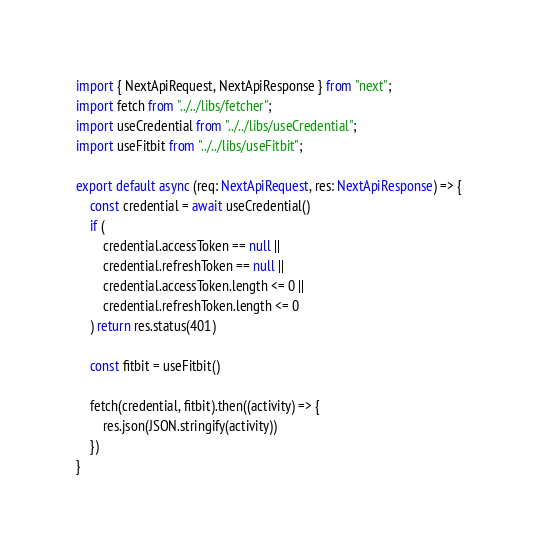<code> <loc_0><loc_0><loc_500><loc_500><_TypeScript_>import { NextApiRequest, NextApiResponse } from "next";
import fetch from "../../libs/fetcher";
import useCredential from "../../libs/useCredential";
import useFitbit from "../../libs/useFitbit";

export default async (req: NextApiRequest, res: NextApiResponse) => {
    const credential = await useCredential()
    if (
        credential.accessToken == null ||
        credential.refreshToken == null ||
        credential.accessToken.length <= 0 ||
        credential.refreshToken.length <= 0
    ) return res.status(401)

    const fitbit = useFitbit()

    fetch(credential, fitbit).then((activity) => {
        res.json(JSON.stringify(activity))
    })
}</code> 